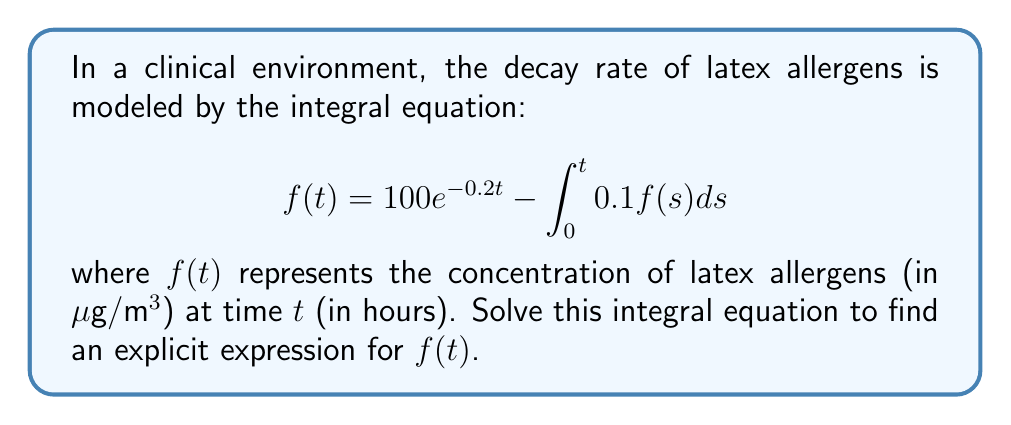What is the answer to this math problem? To solve this integral equation, we'll follow these steps:

1) First, let's differentiate both sides of the equation with respect to $t$:

   $$\frac{d}{dt}f(t) = \frac{d}{dt}(100e^{-0.2t}) - \frac{d}{dt}\int_0^t 0.1f(s)ds$$

2) Using the Fundamental Theorem of Calculus and the chain rule:

   $$f'(t) = -20e^{-0.2t} - 0.1f(t)$$

3) Rearranging the terms:

   $$f'(t) + 0.1f(t) = -20e^{-0.2t}$$

4) This is a first-order linear differential equation. The integrating factor is $e^{0.1t}$. Multiplying both sides by this:

   $$e^{0.1t}f'(t) + 0.1e^{0.1t}f(t) = -20e^{-0.1t}$$

5) The left side is now the derivative of $e^{0.1t}f(t)$:

   $$\frac{d}{dt}(e^{0.1t}f(t)) = -20e^{-0.1t}$$

6) Integrating both sides:

   $$e^{0.1t}f(t) = 200e^{-0.1t} + C$$

7) Solving for $f(t)$:

   $$f(t) = 200e^{-0.2t} + Ce^{-0.1t}$$

8) To find $C$, we use the initial condition $f(0) = 100$:

   $$100 = 200 + C$$
   $$C = -100$$

9) Therefore, the final solution is:

   $$f(t) = 200e^{-0.2t} - 100e^{-0.1t}$$

This expression models the concentration of latex allergens over time in the clinical environment.
Answer: $f(t) = 200e^{-0.2t} - 100e^{-0.1t}$ 